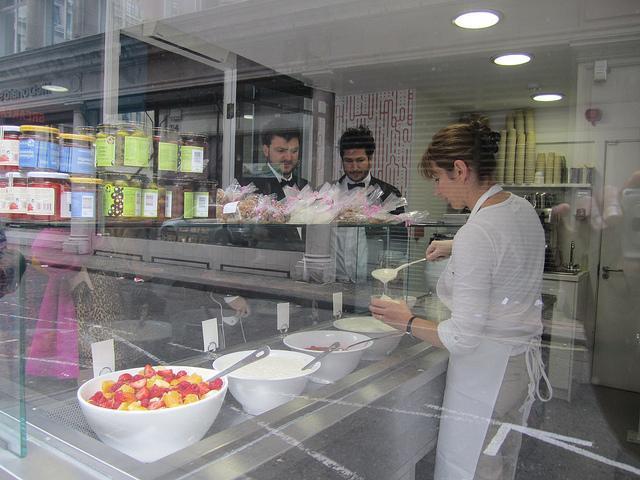How many human hands are shown?
Give a very brief answer. 2. How many bowls can be seen?
Give a very brief answer. 3. How many people are there?
Give a very brief answer. 3. 